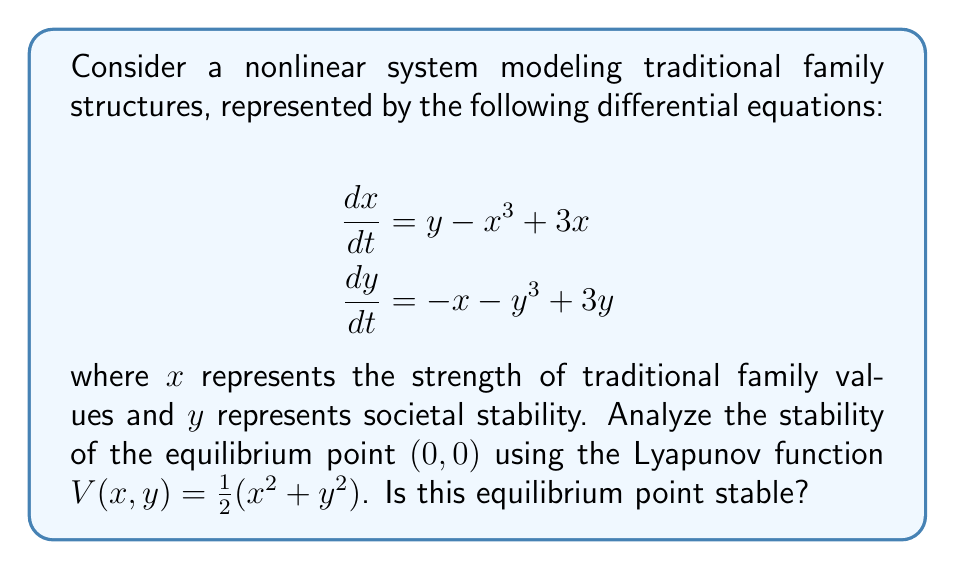Teach me how to tackle this problem. To analyze the stability of the equilibrium point $(0,0)$ using the Lyapunov function $V(x,y) = \frac{1}{2}(x^2 + y^2)$, we follow these steps:

1) First, we verify that $V(0,0) = 0$ and $V(x,y) > 0$ for all $(x,y) \neq (0,0)$. This is true for our given function.

2) Next, we calculate the time derivative of $V$ along the trajectories of the system:

   $$\begin{align}
   \frac{dV}{dt} &= \frac{\partial V}{\partial x}\frac{dx}{dt} + \frac{\partial V}{\partial y}\frac{dy}{dt} \\
   &= x(y - x^3 + 3x) + y(-x - y^3 + 3y) \\
   &= xy - x^4 + 3x^2 - xy - y^4 + 3y^2 \\
   &= -x^4 - y^4 + 3x^2 + 3y^2
   \end{align}$$

3) To determine stability, we need to check if $\frac{dV}{dt} \leq 0$ in a neighborhood of $(0,0)$.

4) Let's examine the behavior of $\frac{dV}{dt}$ near $(0,0)$:
   
   For small $x$ and $y$, the quadratic terms $3x^2$ and $3y^2$ dominate the quartic terms $-x^4$ and $-y^4$.
   
   This means that close to $(0,0)$, we have $\frac{dV}{dt} > 0$.

5) Since $\frac{dV}{dt}$ is positive in a neighborhood of $(0,0)$, the equilibrium point is unstable.

This instability suggests that small deviations from the equilibrium point (representing a balance between traditional family values and societal stability) tend to grow over time in this model.
Answer: Unstable equilibrium point 